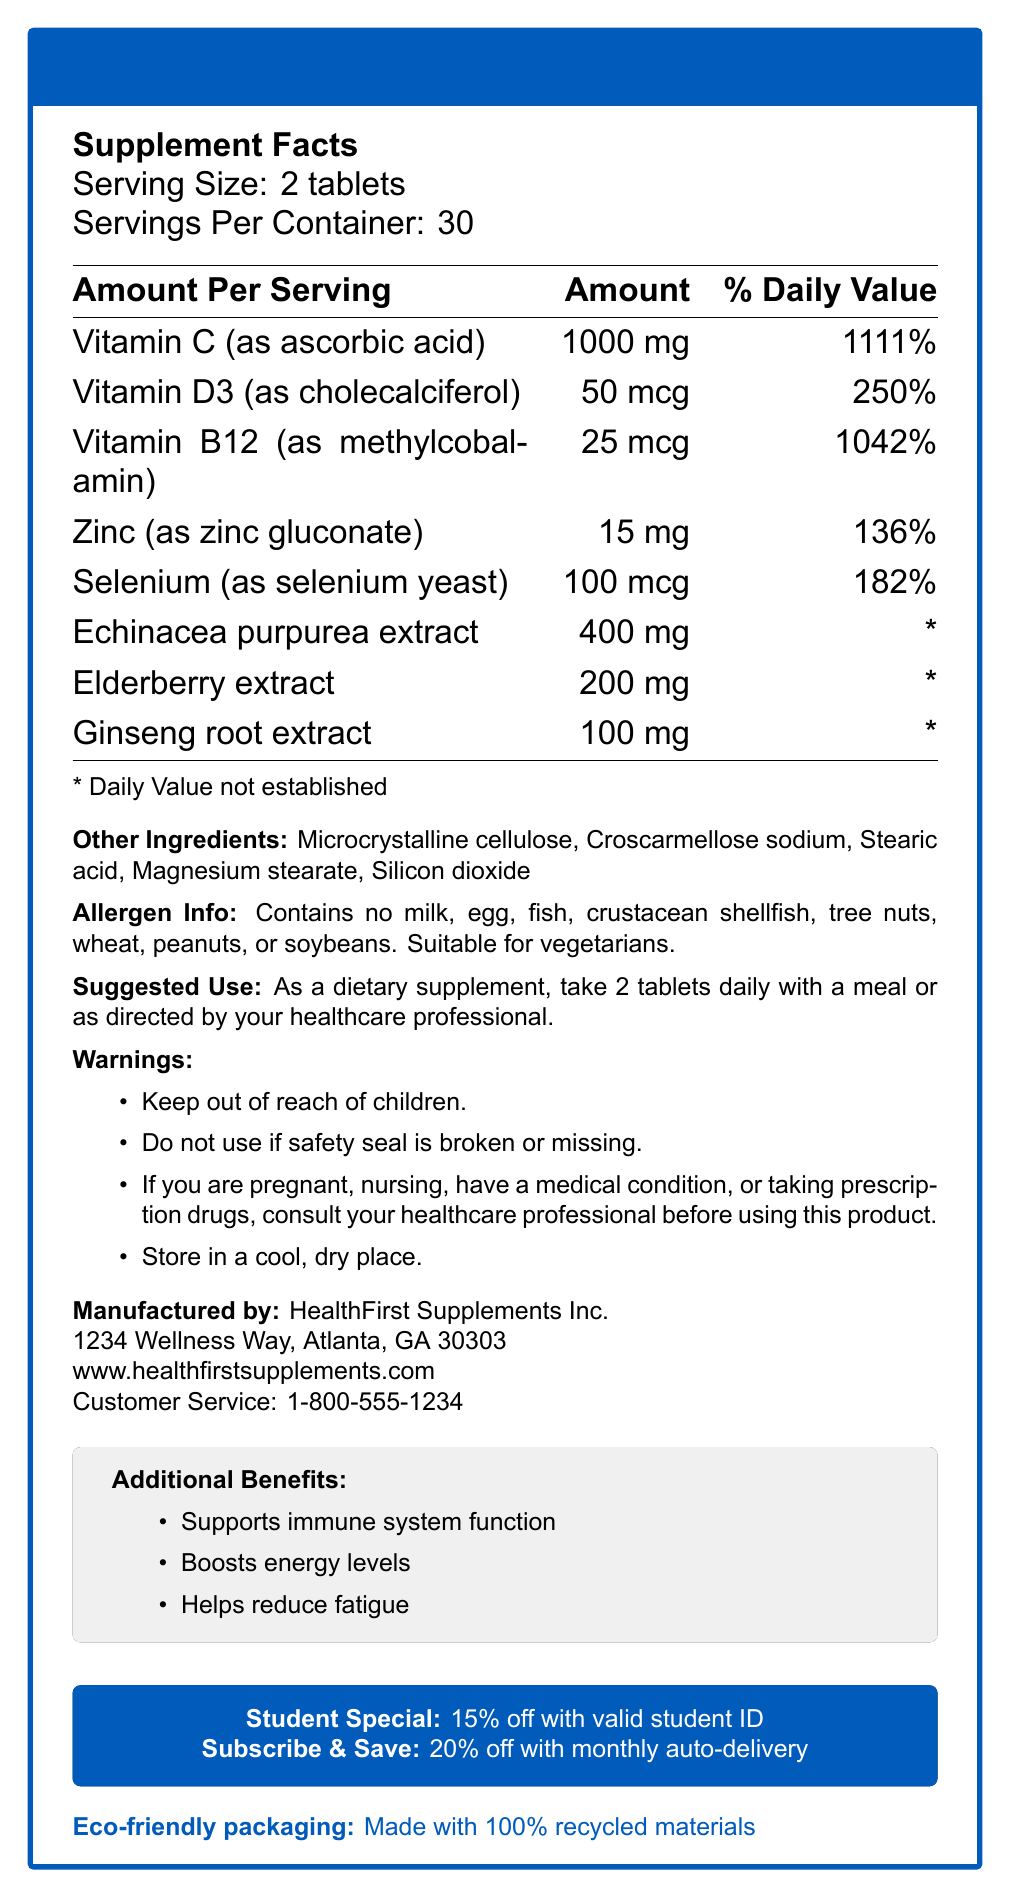what is the serving size for ImmunoBoost Plus Energy? The serving size is mentioned at the beginning of the document under "Serving Size."
Answer: 2 tablets how many servings per container are provided by ImmunoBoost Plus Energy? The number of servings per container is listed as 30 under "Servings Per Container."
Answer: 30 how much Vitamin C is in one serving and what percentage of the daily value does it represent? The document specifies 1000 mg of Vitamin C per serving, which is 1111% of the daily value.
Answer: 1000 mg, 1111% which nutrient has the highest percentage of the daily value? Vitamin C has the highest percentage of the daily value at 1111%.
Answer: Vitamin C what are the first and last other ingredients listed? The other ingredients are listed as Microcrystalline cellulose, Croscarmellose sodium, Stearic acid, Magnesium stearate, Silicon dioxide. The first is Microcrystalline cellulose and the last is Silicon dioxide.
Answer: Microcrystalline cellulose and Silicon dioxide which of the following nutrients does not have a daily value established? A. Vitamin C B. Zinc C. Echinacea purpurea extract D. Vitamin D3 The nutrients Echinacea purpurea extract, Elderberry extract, and Ginseng root extract have a daily value marked as "*", indicating it is not established.
Answer: C. Echinacea purpurea extract how much Zinc is in one serving, and what percentage of the daily value does it represent? The document specifies that each serving contains 15 mg of Zinc, which is 136% of the daily value.
Answer: 15 mg, 136% is ImmunoBoost Plus Energy suitable for vegetarians? The allergen info section of the document states that the supplement is suitable for vegetarians.
Answer: Yes which company's name and address is printed on the document? The manufacturer listed is HealthFirst Supplements Inc. with the address 1234 Wellness Way, Atlanta, GA 30303.
Answer: HealthFirst Supplements Inc., 1234 Wellness Way, Atlanta, GA 30303 if I take 2 tablets daily, how many days will one container last? There are 30 servings per container, and the suggested use is 2 tablets daily, which means one container will last 30 days.
Answer: 30 days which offers are available for students and subscribers? The additional info section describes a 15% discount for students with a valid ID and a 20% discount with monthly auto-delivery.
Answer: 15% off with valid student ID, 20% off with monthly auto-delivery what are the main targeted benefits of ImmunoBoost Plus Energy? The document specifies these three main targeted benefits in the additional info section.
Answer: Supports immune system function, Boosts energy levels, Helps reduce fatigue is the safety seal mentioned in the warnings? The second warning mentions not to use if the safety seal is broken or missing.
Answer: Yes what is the total amount of Elderberry extract in one serving? The document lists 200 mg of Elderberry extract per serving.
Answer: 200 mg summarize the document. The document is an informational label for the ImmunoBoost Plus Energy supplement, providing comprehensive details on its contents, usage instructions, safety warnings, manufacturer information, and special offers.
Answer: The document is a Nutrition Facts Label for a vitamin and mineral supplement called ImmunoBoost Plus Energy by HealthFirst Supplements Inc. It details the amounts and daily values of various nutrients, serving sizes, and container information. It includes other ingredients, allergen info, suggested use, warnings, company contact information, and additional benefits like student discounts and eco-friendly packaging. does the document specify if the supplement is safe for pregnant women to use without consulting a healthcare professional? The warnings state that pregnant women should consult their healthcare professional before using the product.
Answer: No what specific type of Vitamin D3 is included in the supplement? The document specifies that Vitamin D3 in the supplement is cholecalciferol.
Answer: Cholecalciferol which of the following is not listed as an ingredient in the supplement? A. Microcrystalline cellulose B. Stearic acid C. Silicon dioxide D. Gelatin Gelatin is not listed among the ingredients. The listed ingredients are Microcrystalline cellulose, Croscarmellose sodium, Stearic acid, Magnesium stearate, and Silicon dioxide.
Answer: D. Gelatin what should you do if you have a medical condition and want to use this supplement? The warnings section advises consulting a healthcare professional if you have a medical condition before using this product.
Answer: Consult your healthcare professional when should you store this supplement? The storage instruction in the warnings section recommends keeping the supplement in a cool, dry place.
Answer: In a cool, dry place which nutrient found in ImmunoBoost Plus Energy is present in the lowest amount with respect to its weight? Ginseng root extract is listed as 100 mg, which is the lowest amount by weight among the listed nutrients.
Answer: Ginseng root extract, 100 mg 